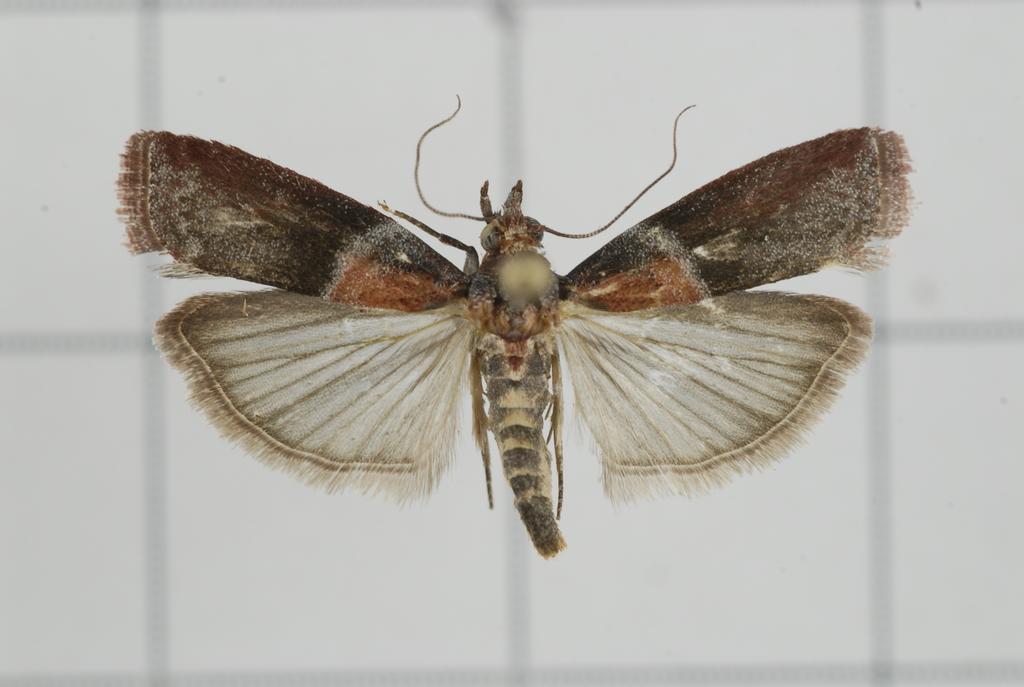Describe this image in one or two sentences. It is an insect which is in brown color. 